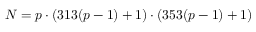Convert formula to latex. <formula><loc_0><loc_0><loc_500><loc_500>N = p \cdot ( 3 1 3 ( p - 1 ) + 1 ) \cdot ( 3 5 3 ( p - 1 ) + 1 )</formula> 